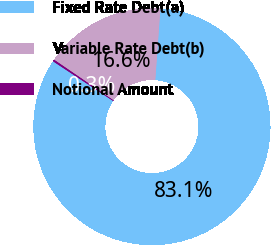Convert chart to OTSL. <chart><loc_0><loc_0><loc_500><loc_500><pie_chart><fcel>Fixed Rate Debt(a)<fcel>Variable Rate Debt(b)<fcel>Notional Amount<nl><fcel>83.14%<fcel>16.59%<fcel>0.26%<nl></chart> 